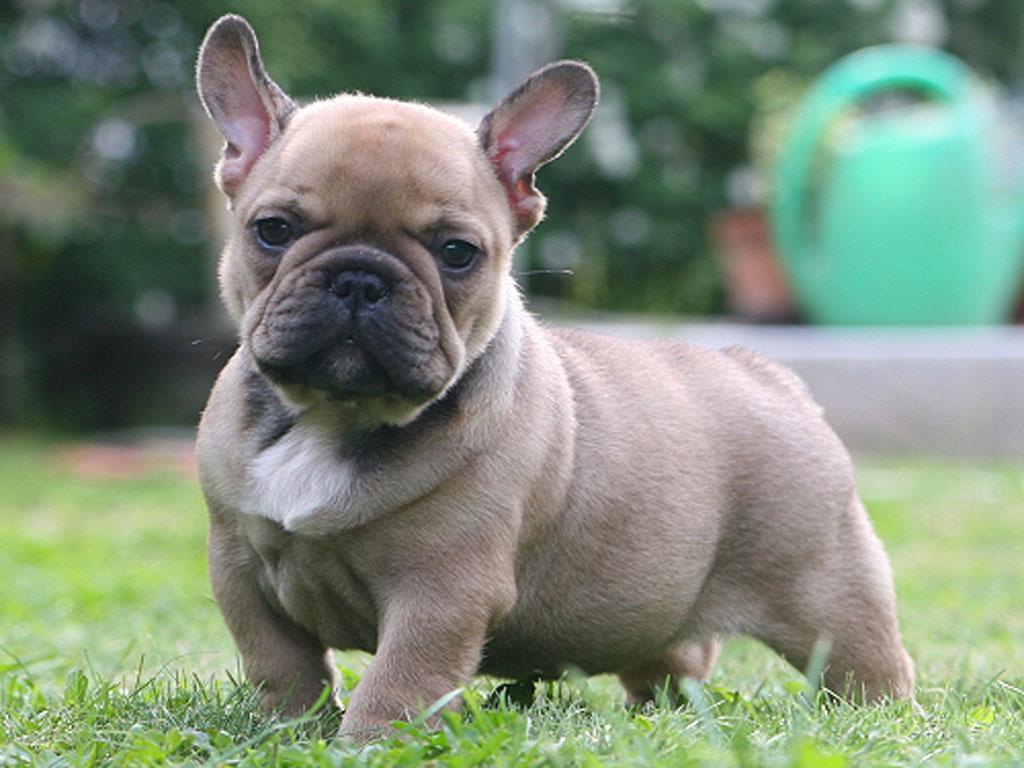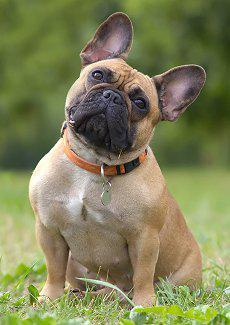The first image is the image on the left, the second image is the image on the right. Examine the images to the left and right. Is the description "At least one of the dogs is in the grass." accurate? Answer yes or no. Yes. 